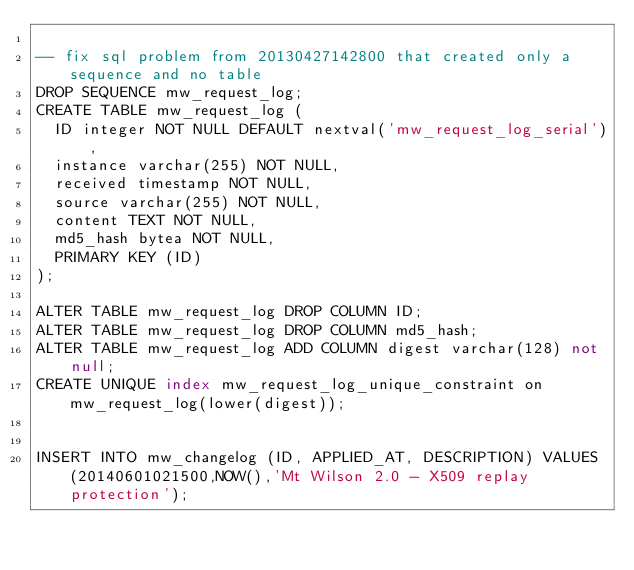<code> <loc_0><loc_0><loc_500><loc_500><_SQL_>
-- fix sql problem from 20130427142800 that created only a sequence and no table
DROP SEQUENCE mw_request_log;
CREATE TABLE mw_request_log (
  ID integer NOT NULL DEFAULT nextval('mw_request_log_serial'),
  instance varchar(255) NOT NULL,
  received timestamp NOT NULL,
  source varchar(255) NOT NULL,
  content TEXT NOT NULL,
  md5_hash bytea NOT NULL, 
  PRIMARY KEY (ID)
);

ALTER TABLE mw_request_log DROP COLUMN ID;
ALTER TABLE mw_request_log DROP COLUMN md5_hash;
ALTER TABLE mw_request_log ADD COLUMN digest varchar(128) not null;
CREATE UNIQUE index mw_request_log_unique_constraint on mw_request_log(lower(digest));


INSERT INTO mw_changelog (ID, APPLIED_AT, DESCRIPTION) VALUES (20140601021500,NOW(),'Mt Wilson 2.0 - X509 replay protection');
</code> 